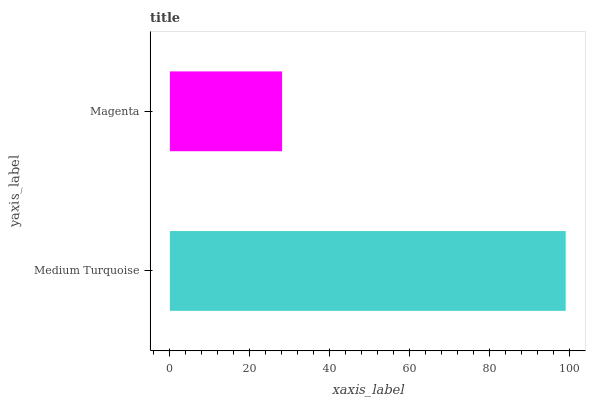Is Magenta the minimum?
Answer yes or no. Yes. Is Medium Turquoise the maximum?
Answer yes or no. Yes. Is Magenta the maximum?
Answer yes or no. No. Is Medium Turquoise greater than Magenta?
Answer yes or no. Yes. Is Magenta less than Medium Turquoise?
Answer yes or no. Yes. Is Magenta greater than Medium Turquoise?
Answer yes or no. No. Is Medium Turquoise less than Magenta?
Answer yes or no. No. Is Medium Turquoise the high median?
Answer yes or no. Yes. Is Magenta the low median?
Answer yes or no. Yes. Is Magenta the high median?
Answer yes or no. No. Is Medium Turquoise the low median?
Answer yes or no. No. 